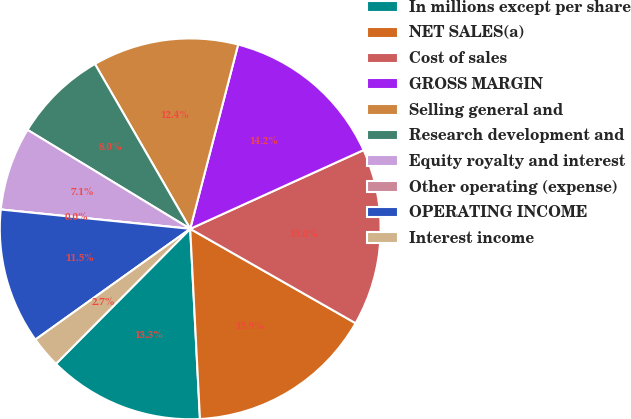Convert chart to OTSL. <chart><loc_0><loc_0><loc_500><loc_500><pie_chart><fcel>In millions except per share<fcel>NET SALES(a)<fcel>Cost of sales<fcel>GROSS MARGIN<fcel>Selling general and<fcel>Research development and<fcel>Equity royalty and interest<fcel>Other operating (expense)<fcel>OPERATING INCOME<fcel>Interest income<nl><fcel>13.27%<fcel>15.93%<fcel>15.04%<fcel>14.16%<fcel>12.39%<fcel>7.96%<fcel>7.08%<fcel>0.0%<fcel>11.5%<fcel>2.66%<nl></chart> 